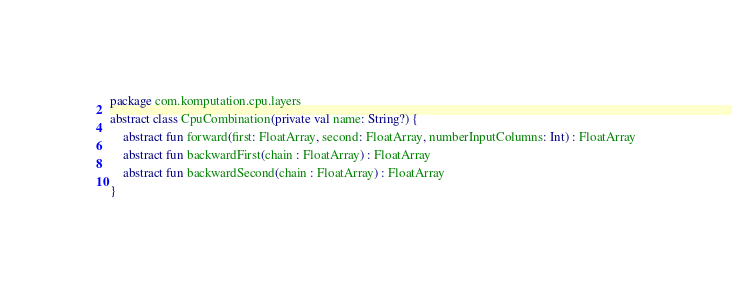<code> <loc_0><loc_0><loc_500><loc_500><_Kotlin_>package com.komputation.cpu.layers

abstract class CpuCombination(private val name: String?) {

    abstract fun forward(first: FloatArray, second: FloatArray, numberInputColumns: Int) : FloatArray

    abstract fun backwardFirst(chain : FloatArray) : FloatArray

    abstract fun backwardSecond(chain : FloatArray) : FloatArray

}</code> 